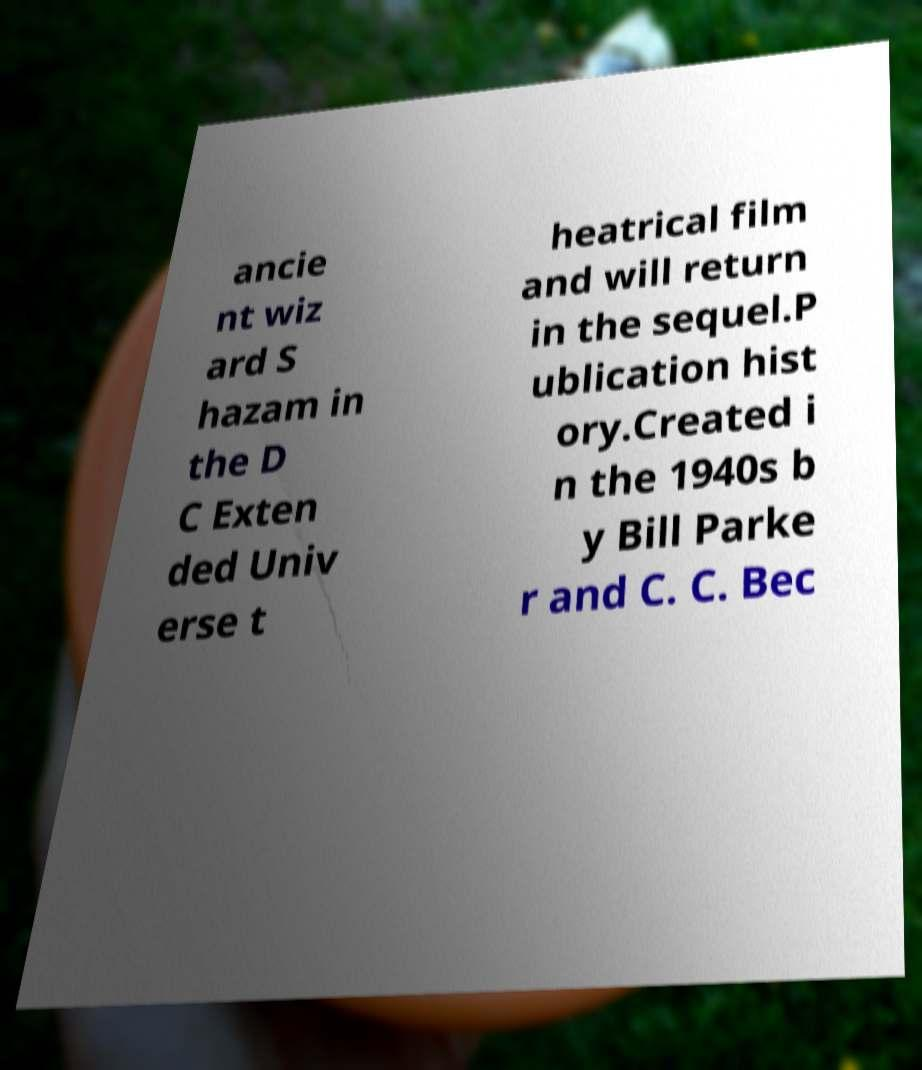There's text embedded in this image that I need extracted. Can you transcribe it verbatim? ancie nt wiz ard S hazam in the D C Exten ded Univ erse t heatrical film and will return in the sequel.P ublication hist ory.Created i n the 1940s b y Bill Parke r and C. C. Bec 